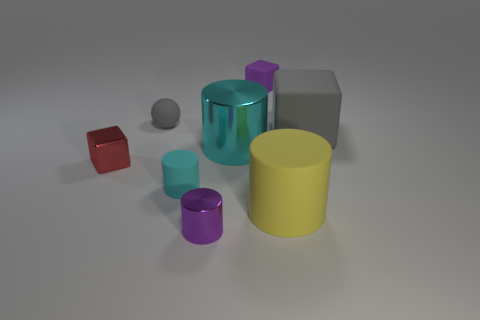Add 1 red metal balls. How many objects exist? 9 Subtract all small blocks. How many blocks are left? 1 Subtract all yellow cylinders. How many cylinders are left? 3 Subtract all blocks. How many objects are left? 5 Subtract 2 blocks. How many blocks are left? 1 Subtract all brown cylinders. Subtract all cyan blocks. How many cylinders are left? 4 Subtract all brown cubes. How many purple cylinders are left? 1 Subtract all spheres. Subtract all gray matte blocks. How many objects are left? 6 Add 2 small cubes. How many small cubes are left? 4 Add 1 tiny gray metallic things. How many tiny gray metallic things exist? 1 